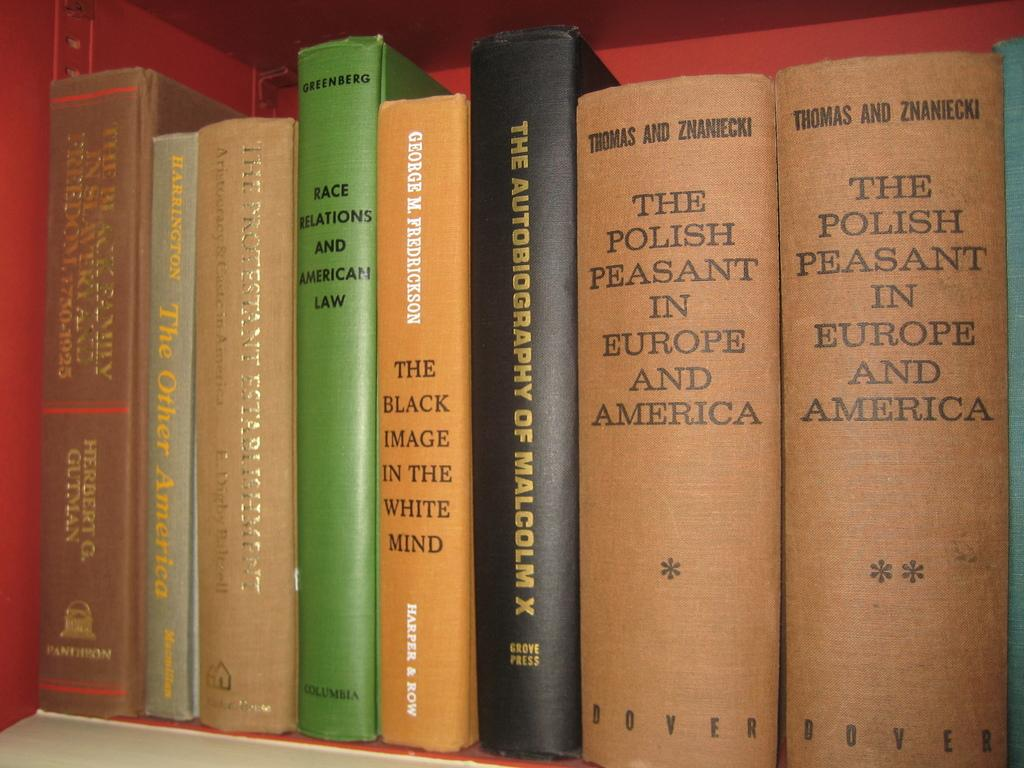Provide a one-sentence caption for the provided image. Two volumes of, "The Polish Peasant in Europe and America" are on a bookshelf with other books. 